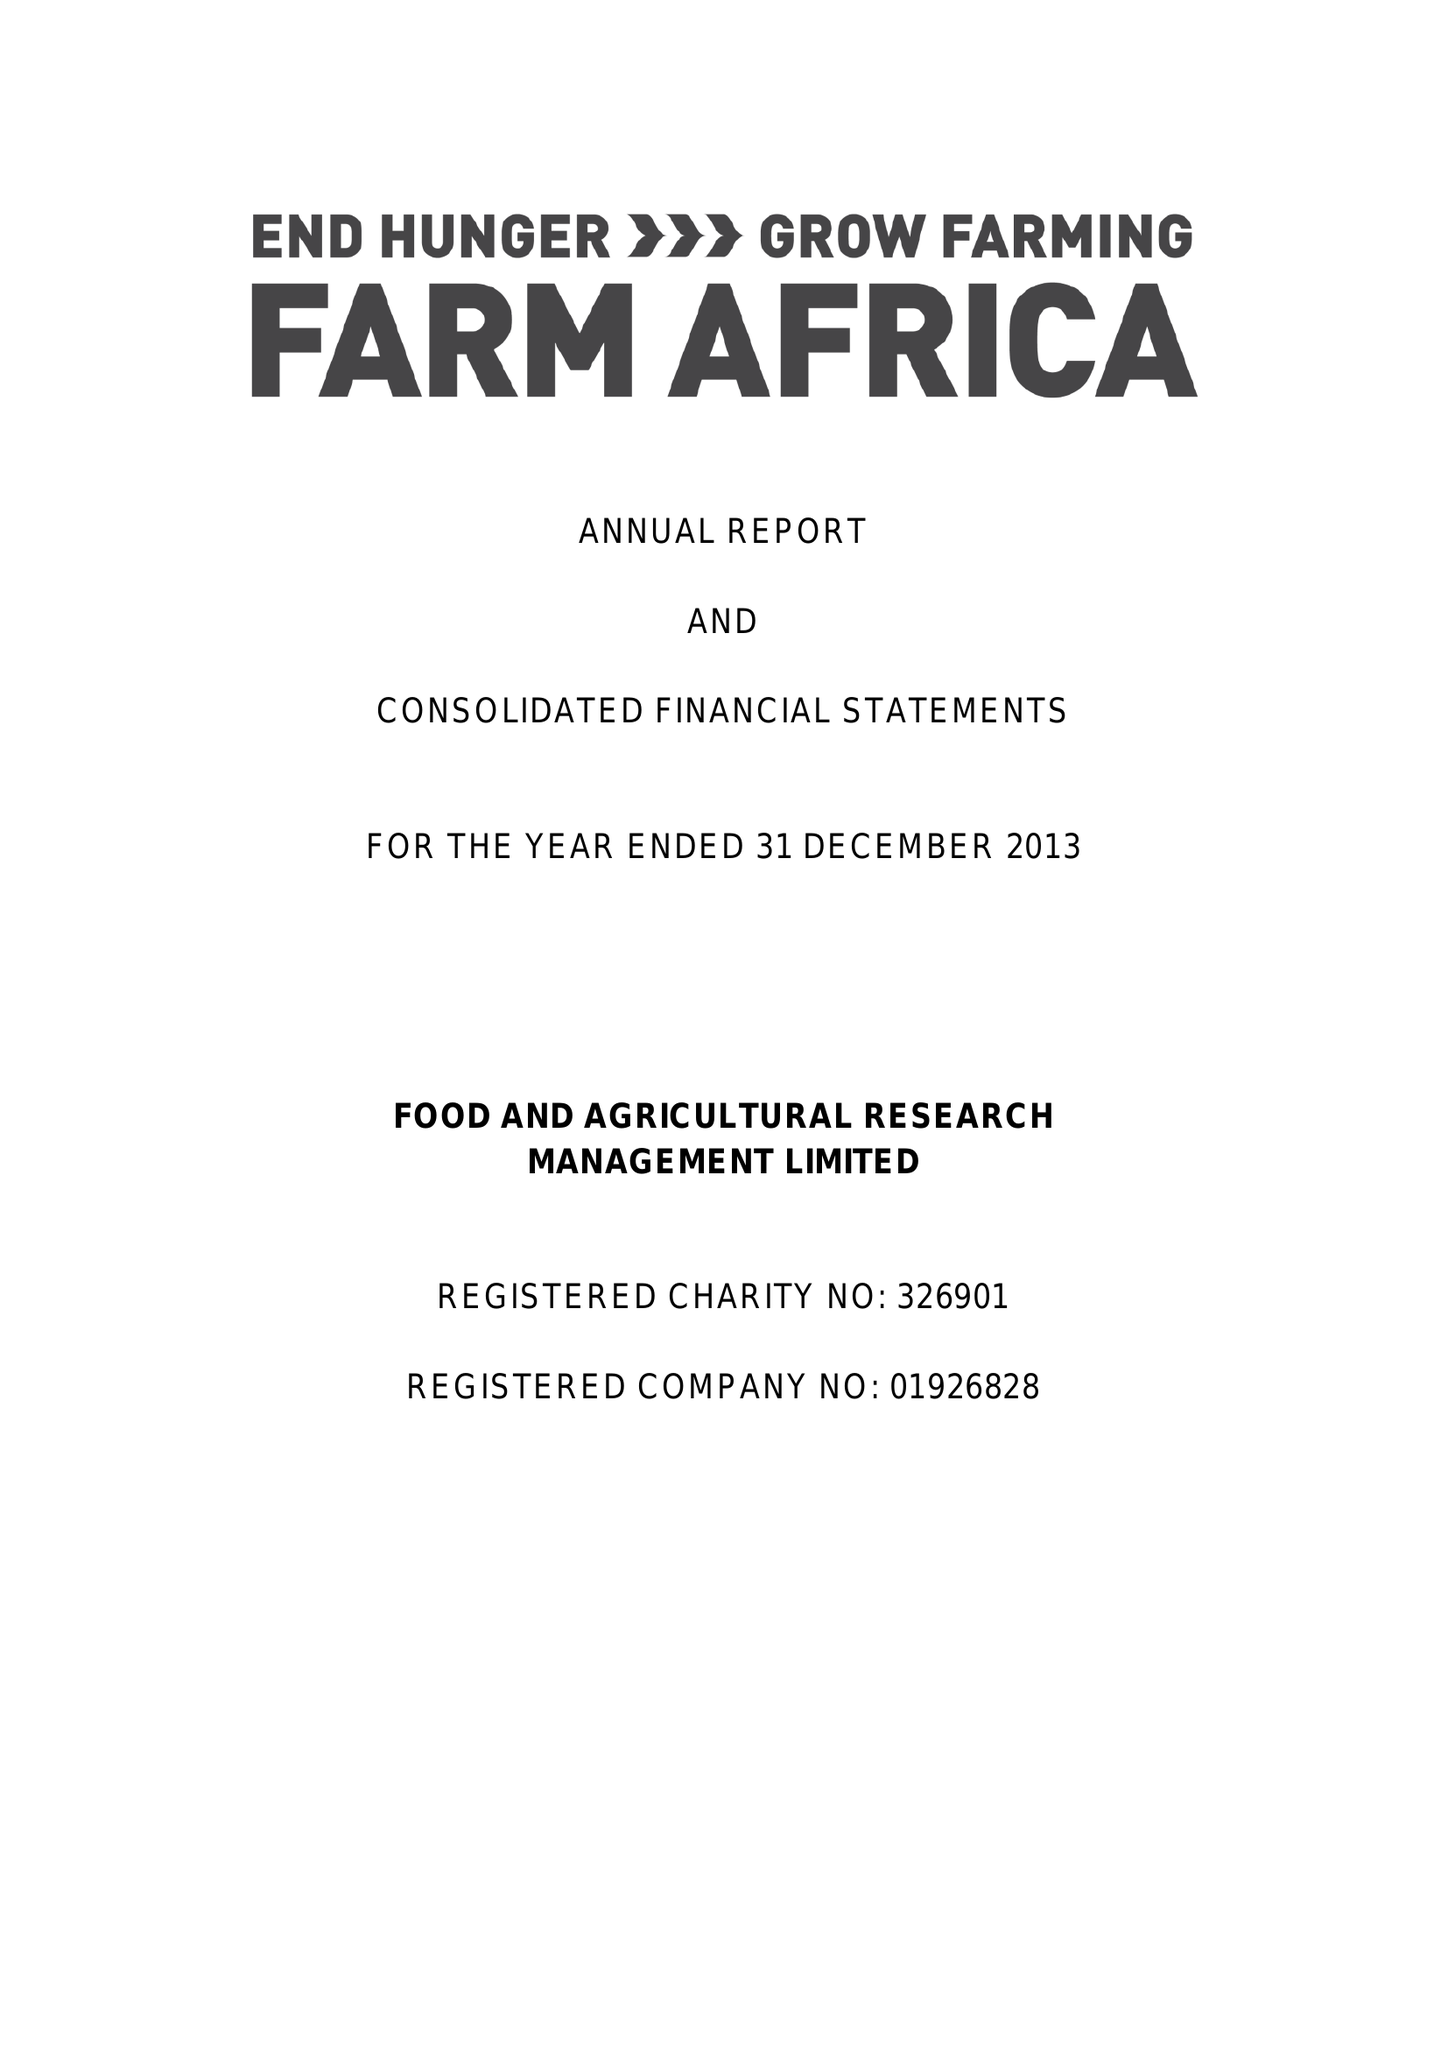What is the value for the charity_number?
Answer the question using a single word or phrase. 326901 